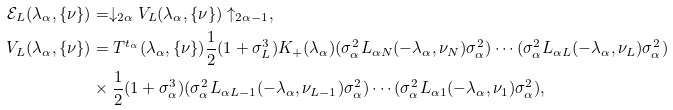Convert formula to latex. <formula><loc_0><loc_0><loc_500><loc_500>\mathcal { E } _ { L } ( \lambda _ { \alpha } , \{ \nu \} ) & = \downarrow _ { 2 \alpha } V _ { L } ( \lambda _ { \alpha } , \{ \nu \} ) \uparrow _ { 2 \alpha - 1 } , \\ V _ { L } ( \lambda _ { \alpha } , \{ \nu \} ) & = T ^ { t _ { \alpha } } ( \lambda _ { \alpha } , \{ \nu \} ) \frac { 1 } { 2 } ( 1 + \sigma _ { L } ^ { 3 } ) K _ { + } ( \lambda _ { \alpha } ) ( \sigma _ { \alpha } ^ { 2 } L _ { \alpha N } ( - \lambda _ { \alpha } , \nu _ { N } ) \sigma _ { \alpha } ^ { 2 } ) \cdots ( \sigma _ { \alpha } ^ { 2 } L _ { \alpha L } ( - \lambda _ { \alpha } , \nu _ { L } ) \sigma _ { \alpha } ^ { 2 } ) \\ & \times \frac { 1 } { 2 } ( 1 + \sigma _ { \alpha } ^ { 3 } ) ( \sigma _ { \alpha } ^ { 2 } L _ { \alpha L - 1 } ( - \lambda _ { \alpha } , \nu _ { L - 1 } ) \sigma _ { \alpha } ^ { 2 } ) \cdots ( \sigma _ { \alpha } ^ { 2 } L _ { \alpha 1 } ( - \lambda _ { \alpha } , \nu _ { 1 } ) \sigma _ { \alpha } ^ { 2 } ) ,</formula> 